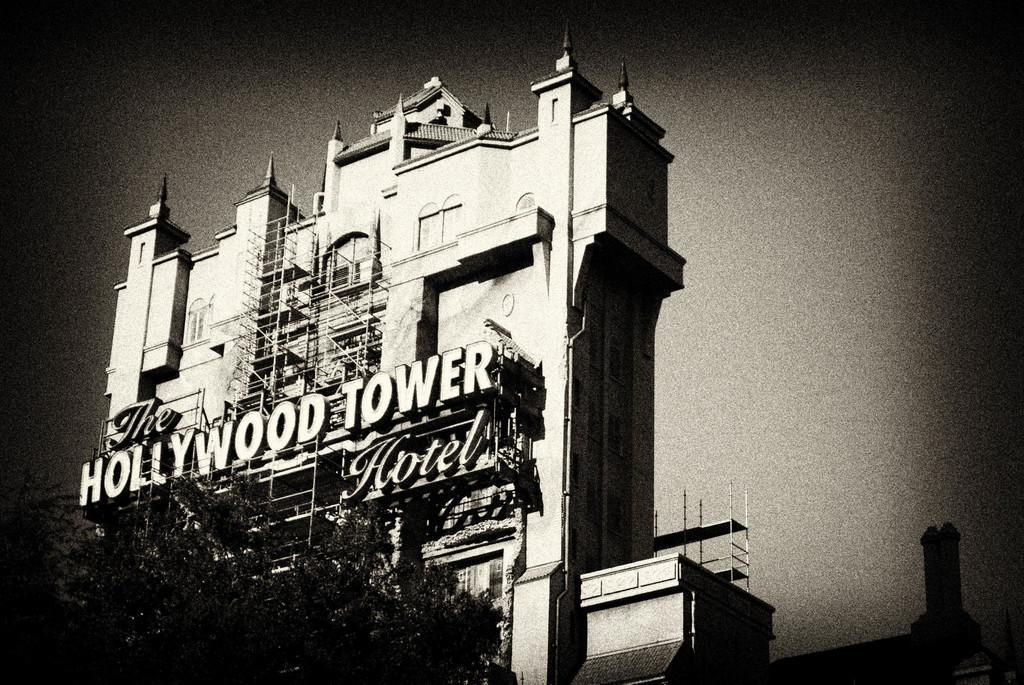What type of structure is visible in the image? There is a building in the image. What other natural elements can be seen in the image? There are trees in the image. What is the color scheme of the image? The image is in black and white. How many legs can be seen supporting the building in the image? There are no legs visible in the image, as buildings typically do not have legs for support. 